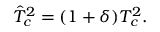<formula> <loc_0><loc_0><loc_500><loc_500>\hat { T } _ { c } ^ { 2 } = ( 1 + \delta ) T _ { c } ^ { 2 } .</formula> 